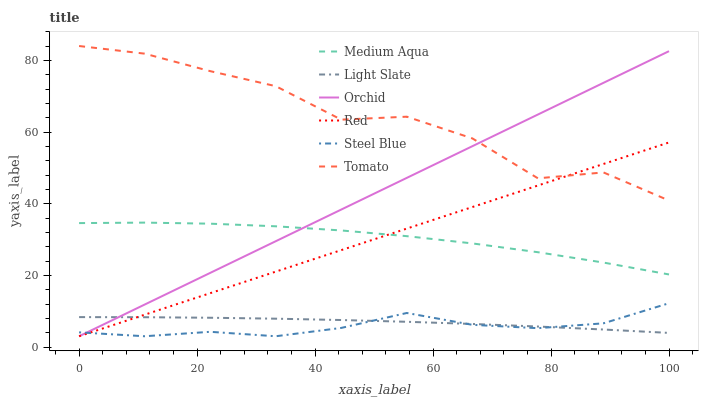Does Steel Blue have the minimum area under the curve?
Answer yes or no. Yes. Does Tomato have the maximum area under the curve?
Answer yes or no. Yes. Does Light Slate have the minimum area under the curve?
Answer yes or no. No. Does Light Slate have the maximum area under the curve?
Answer yes or no. No. Is Orchid the smoothest?
Answer yes or no. Yes. Is Tomato the roughest?
Answer yes or no. Yes. Is Light Slate the smoothest?
Answer yes or no. No. Is Light Slate the roughest?
Answer yes or no. No. Does Steel Blue have the lowest value?
Answer yes or no. Yes. Does Light Slate have the lowest value?
Answer yes or no. No. Does Tomato have the highest value?
Answer yes or no. Yes. Does Steel Blue have the highest value?
Answer yes or no. No. Is Steel Blue less than Tomato?
Answer yes or no. Yes. Is Medium Aqua greater than Light Slate?
Answer yes or no. Yes. Does Tomato intersect Red?
Answer yes or no. Yes. Is Tomato less than Red?
Answer yes or no. No. Is Tomato greater than Red?
Answer yes or no. No. Does Steel Blue intersect Tomato?
Answer yes or no. No. 